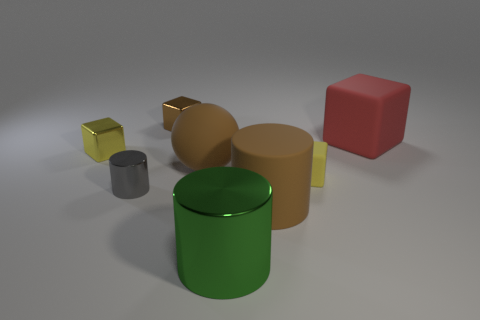There is a large matte object right of the brown cylinder; how many green metal objects are on the right side of it?
Provide a succinct answer. 0. Does the small cube right of the tiny brown metal thing have the same material as the small object that is behind the large red block?
Offer a terse response. No. What is the material of the cylinder that is the same color as the large sphere?
Give a very brief answer. Rubber. How many big red things are the same shape as the brown shiny object?
Ensure brevity in your answer.  1. Does the brown cylinder have the same material as the cube that is in front of the large sphere?
Provide a short and direct response. Yes. There is a red block that is the same size as the brown rubber cylinder; what is its material?
Keep it short and to the point. Rubber. Are there any brown balls of the same size as the rubber cylinder?
Offer a very short reply. Yes. The red thing that is the same size as the green metal object is what shape?
Ensure brevity in your answer.  Cube. What number of other objects are there of the same color as the big sphere?
Provide a succinct answer. 2. There is a rubber object that is both behind the large matte cylinder and on the left side of the small rubber thing; what shape is it?
Provide a short and direct response. Sphere. 